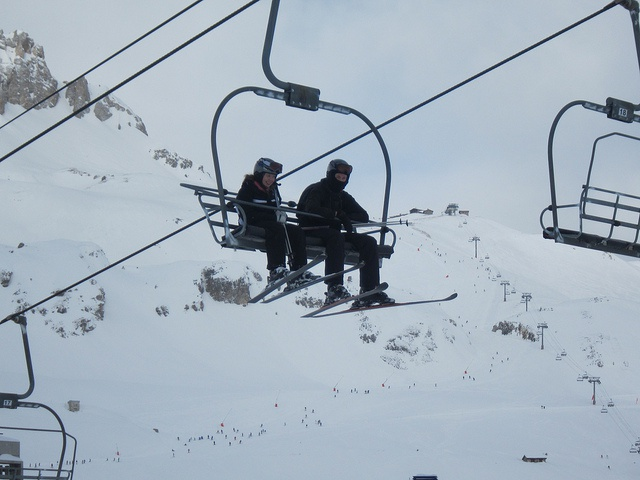Describe the objects in this image and their specific colors. I can see people in lightgray, black, gray, and darkblue tones, bench in lightgray, darkgray, gray, and black tones, people in lightgray, black, gray, and darkblue tones, skis in lightgray, darkblue, gray, and black tones, and skis in lightgray, gray, black, and darkblue tones in this image. 